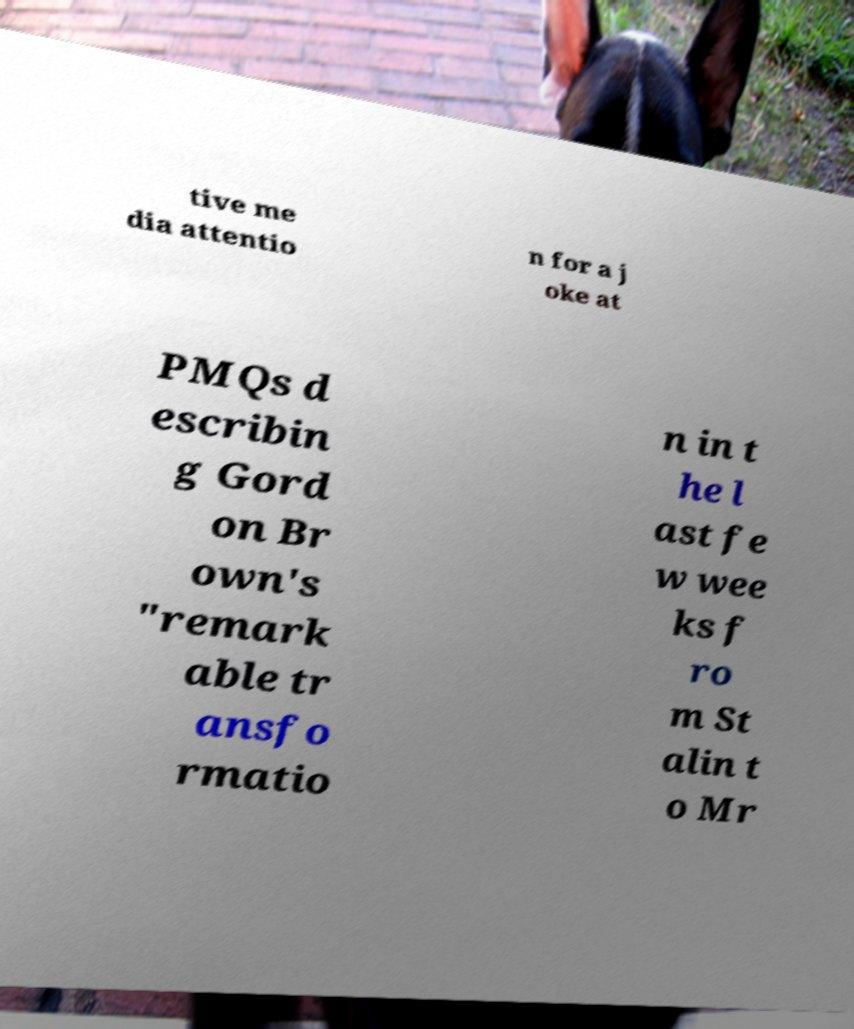Can you read and provide the text displayed in the image?This photo seems to have some interesting text. Can you extract and type it out for me? tive me dia attentio n for a j oke at PMQs d escribin g Gord on Br own's "remark able tr ansfo rmatio n in t he l ast fe w wee ks f ro m St alin t o Mr 